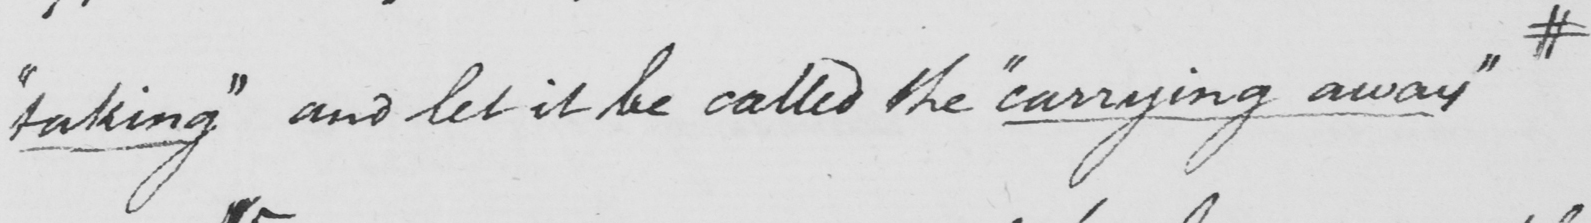Please provide the text content of this handwritten line. " taking "  and let it be called the  " carrying away "  # 